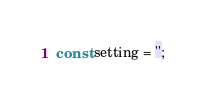<code> <loc_0><loc_0><loc_500><loc_500><_JavaScript_>const setting = '';
</code> 